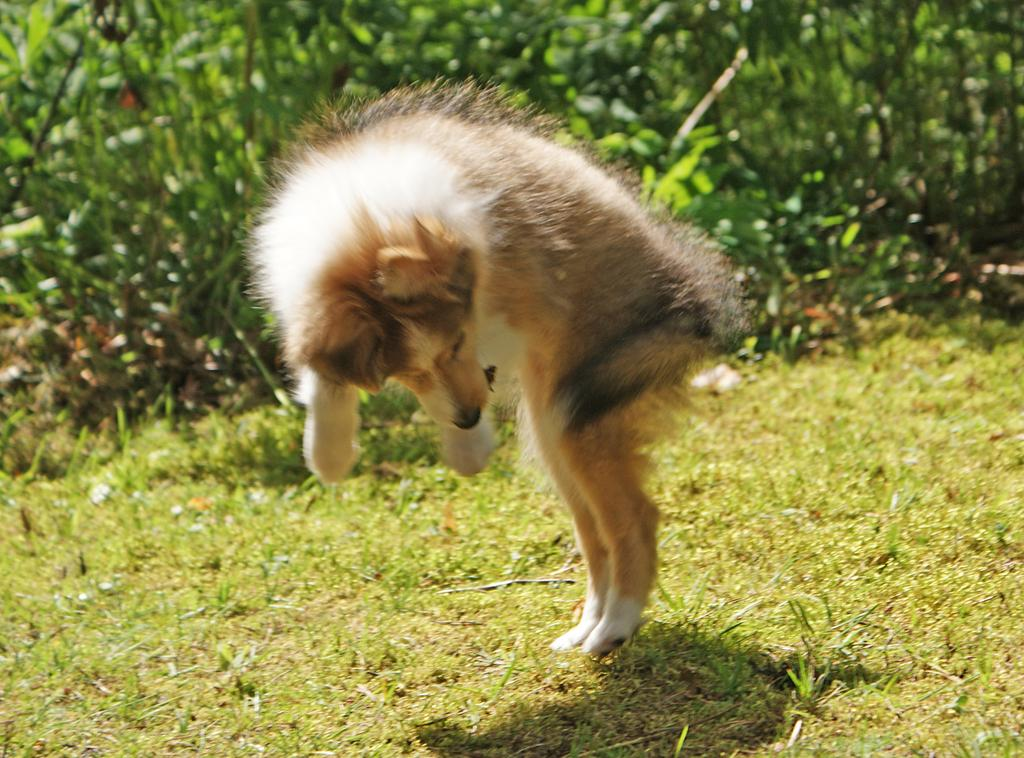What animal is present in the image? There is a dog in the image. Where is the dog located? The dog is in a garden. What can be seen in the background of the image? There are plants in the background of the image. What type of knot can be seen tied around the dog's neck in the image? There is no knot tied around the dog's neck in the image. Is there a river visible in the background of the image? No, there is no river visible in the image; only plants are present in the background. 